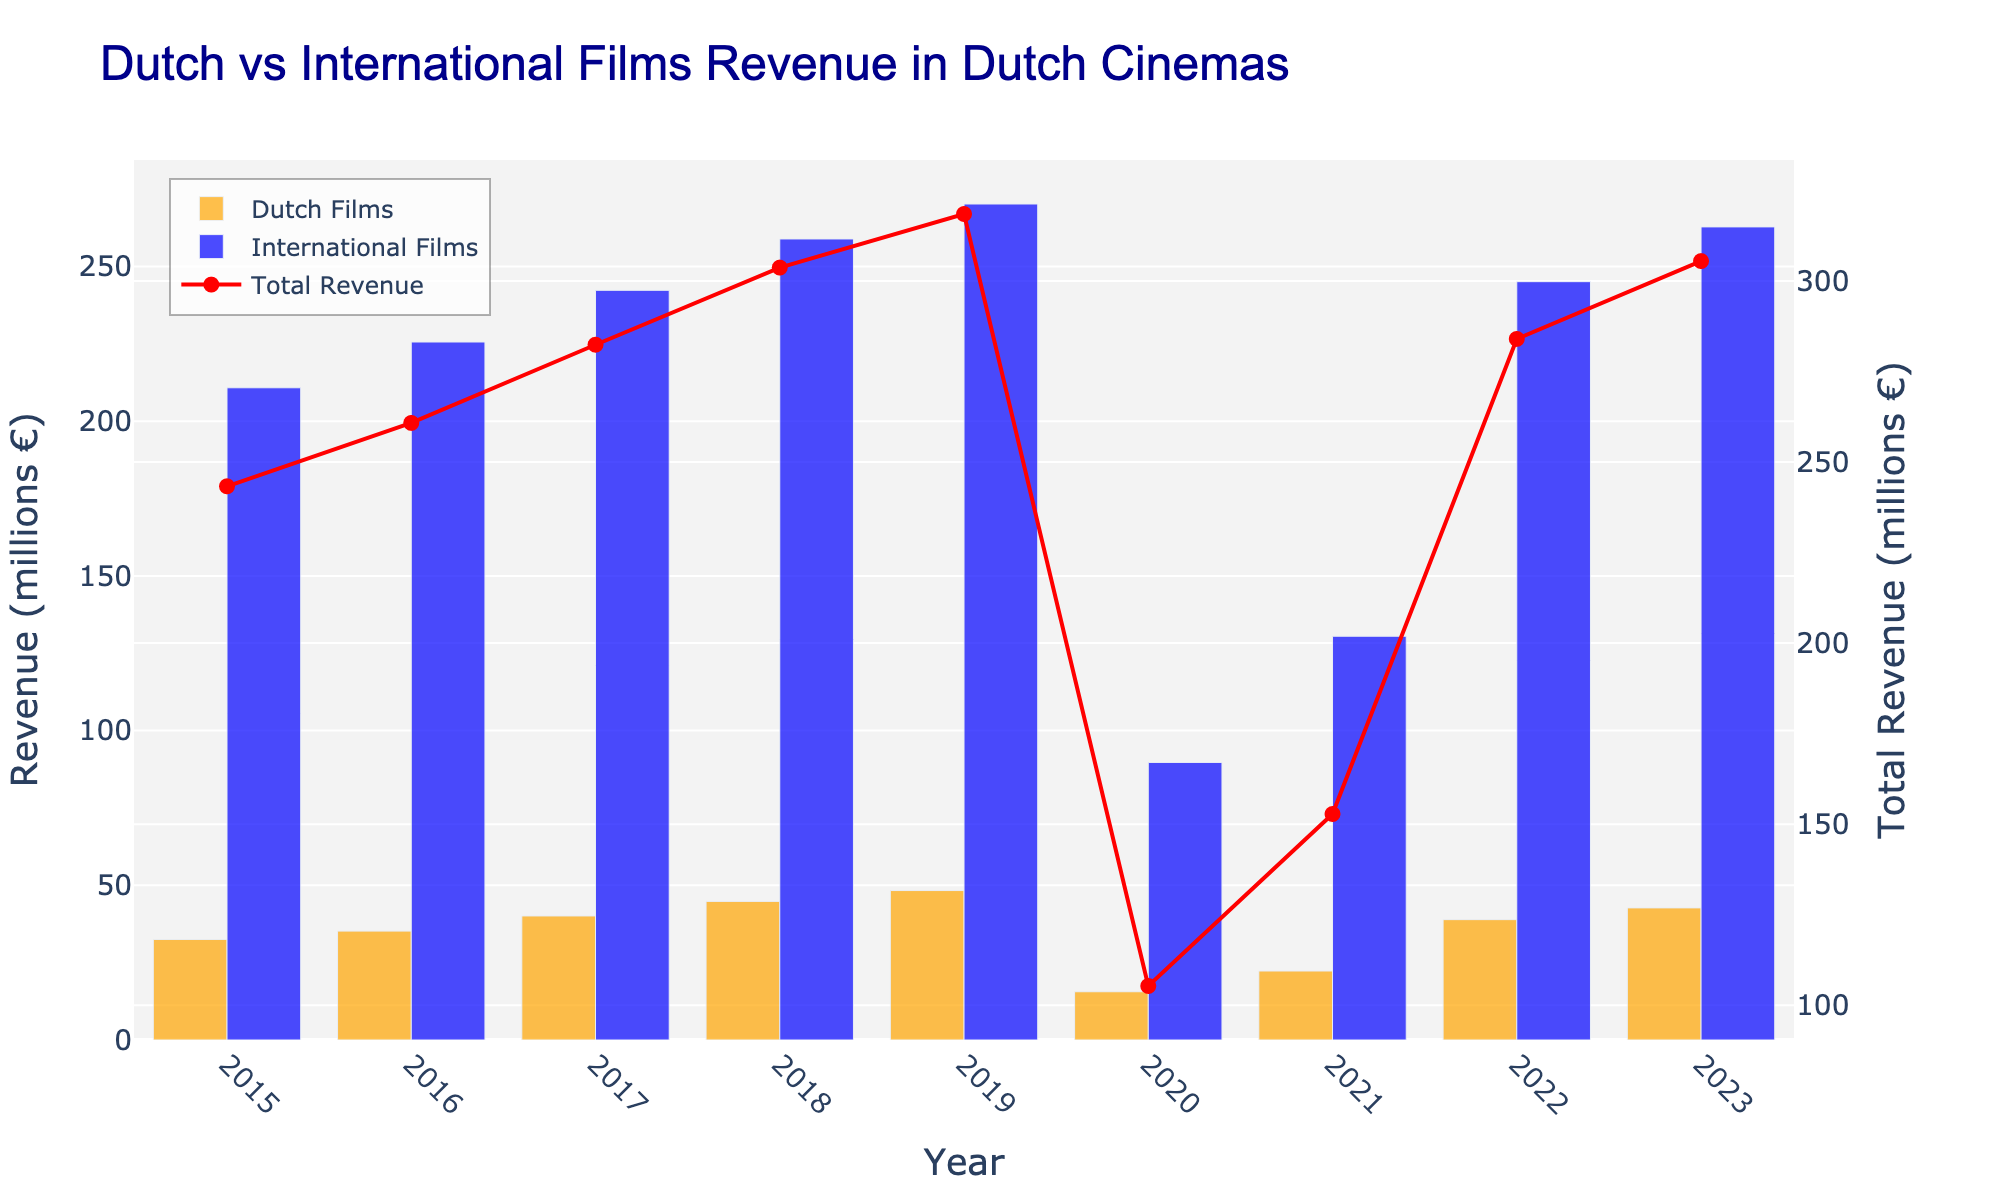Which year had the highest revenue for international films? Look for the tallest blue bar, which corresponds to the international films revenue, and identify the year. The tallest blue bar is in 2019.
Answer: 2019 What was the total revenue in Dutch cinemas in 2023? Refer to the red line with markers for the total revenue and find the data point for the year 2023. The total revenue for 2023 is approximately 305.5 million €.
Answer: 305.5 million € How did the Dutch films' revenue in 2016 compare to 2015? Compare the heights of the orange bars for 2015 and 2016. The orange bar for 2016 is higher than for 2015, indicating an increase. The difference is 35.2 - 32.5 = 2.7 million €.
Answer: Increased by 2.7 million € What is the difference between the Dutch and international films' revenues in 2020? Look at the heights of the orange and blue bars in 2020. Subtract the Dutch films' revenue from the international films' revenue. The difference is 89.7 - 15.6 = 74.1 million €.
Answer: 74.1 million € Which year had the smallest revenue gap between Dutch and international films? Calculate the revenue difference for each year and identify the year with the smallest gap. For 2021, the gap is 130.5 - 22.3 = 108.2 million €, which is the smallest.
Answer: 2021 In which year did Dutch films' revenue surpass 40 million € for the first time? Identify the year when the orange bar first exceeds 40 million €. This occurs in 2017 when the revenue is 40.1 million €.
Answer: 2017 By how much did the total revenue increase from 2015 to 2019? Find the total revenue for 2015 and 2019 and calculate the difference. For 2015, it is 32.5 + 210.8 = 243.3 million € and for 2019, it is 48.3 + 270.2 = 318.5 million €. The increase is 318.5 - 243.3 = 75.2 million €.
Answer: 75.2 million € What was the average annual revenue for international films from 2015 to 2019? Sum the revenues from 2015 to 2019 and divide by the number of years. (210.8 + 225.6 + 242.3 + 258.9 + 270.2) / 5 = 241.56 million €.
Answer: 241.56 million € How does the 2022 total revenue compare to the 2020 total revenue? Calculate the total revenue for both years and compare. For 2022, it is 38.9 + 245.1 = 284 million € and for 2020, it is 15.6 + 89.7 = 105.3 million €. The 2022 revenue is greater by 284 - 105.3 = 178.7 million €.
Answer: 178.7 million € What is the trend of the Dutch films' revenue from 2015 to 2023? Observe the progression of the orange bars over the years. The orange bars generally increase from 2015 to 2019, drop significantly in 2020, then increase again from 2021 to 2023.
Answer: Initially increasing, drop in 2020, then increasing again 